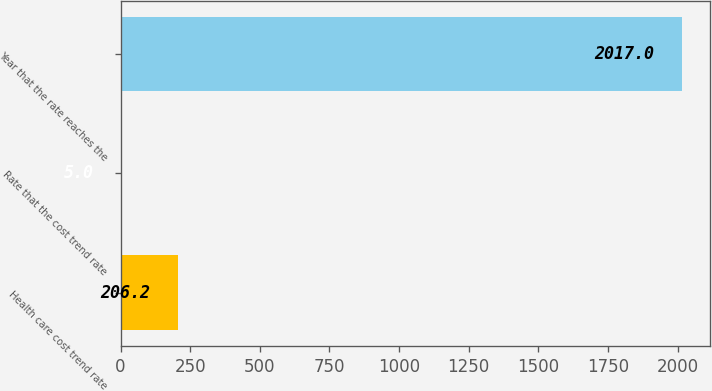Convert chart. <chart><loc_0><loc_0><loc_500><loc_500><bar_chart><fcel>Health care cost trend rate<fcel>Rate that the cost trend rate<fcel>Year that the rate reaches the<nl><fcel>206.2<fcel>5<fcel>2017<nl></chart> 